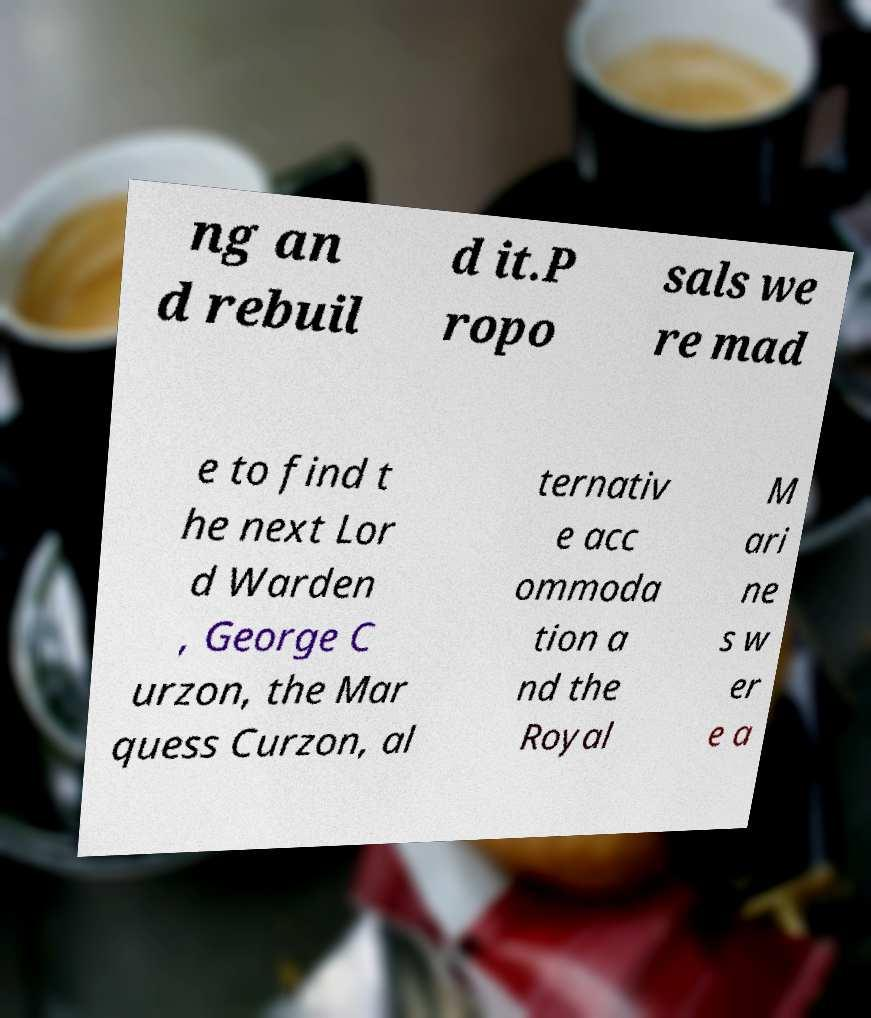Can you read and provide the text displayed in the image?This photo seems to have some interesting text. Can you extract and type it out for me? ng an d rebuil d it.P ropo sals we re mad e to find t he next Lor d Warden , George C urzon, the Mar quess Curzon, al ternativ e acc ommoda tion a nd the Royal M ari ne s w er e a 